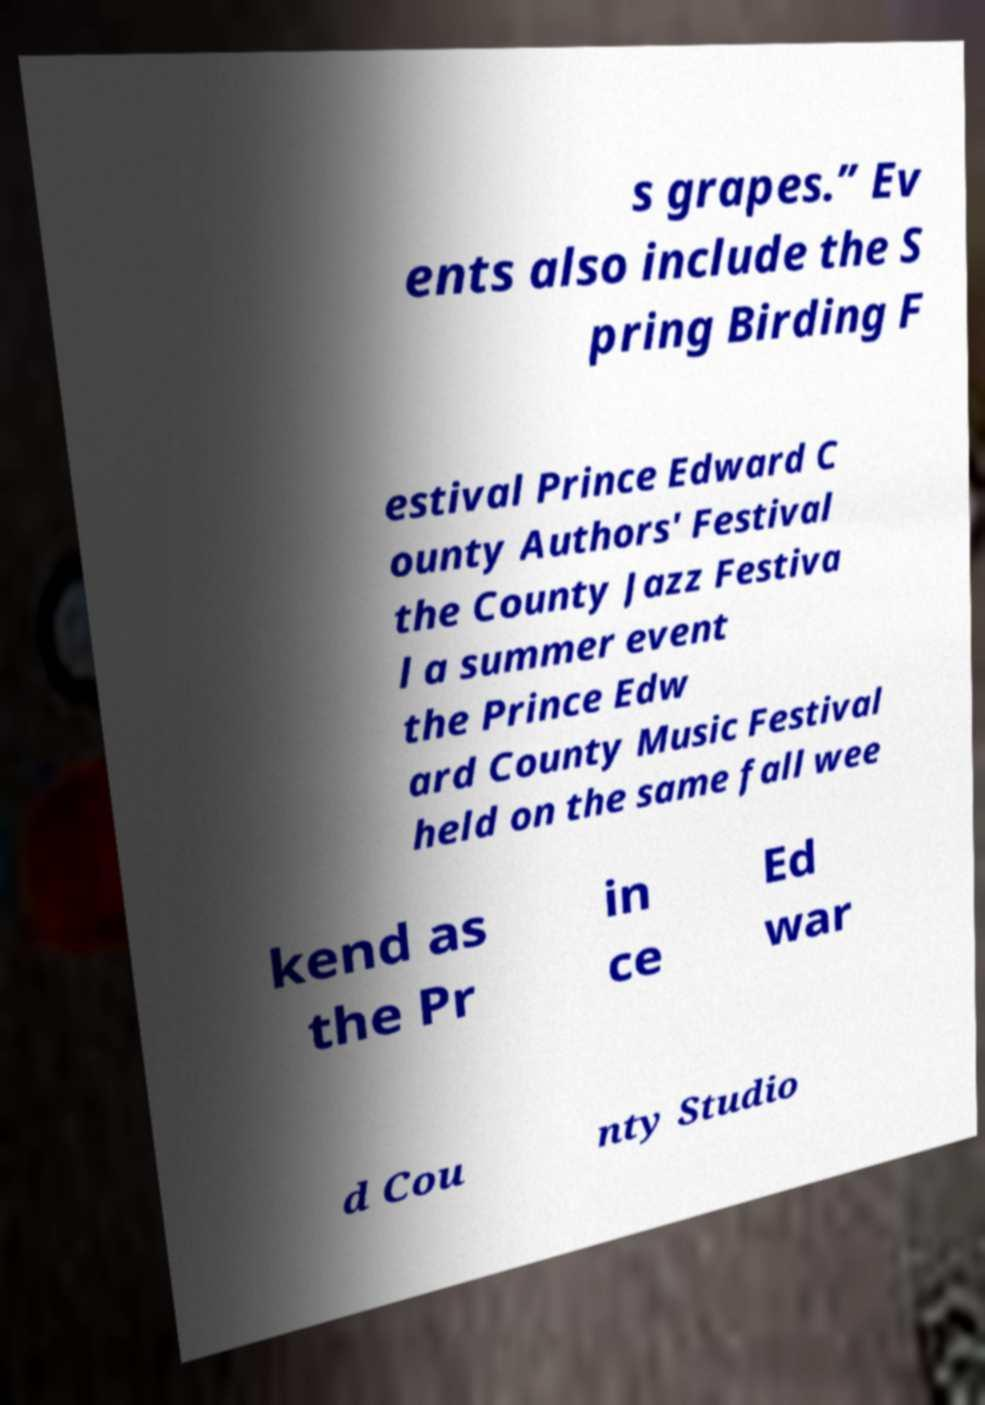Could you extract and type out the text from this image? s grapes.” Ev ents also include the S pring Birding F estival Prince Edward C ounty Authors' Festival the County Jazz Festiva l a summer event the Prince Edw ard County Music Festival held on the same fall wee kend as the Pr in ce Ed war d Cou nty Studio 